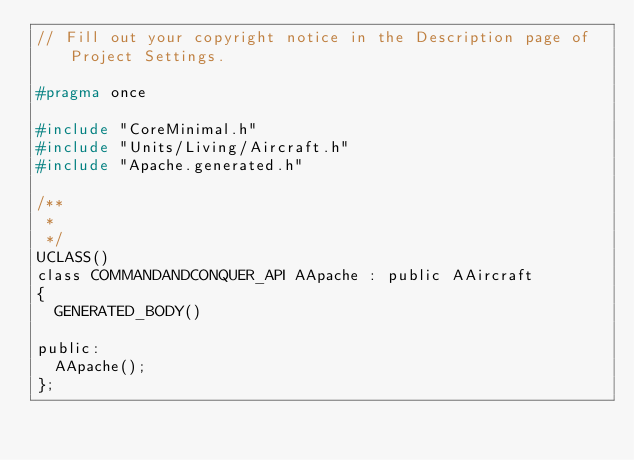Convert code to text. <code><loc_0><loc_0><loc_500><loc_500><_C_>// Fill out your copyright notice in the Description page of Project Settings.

#pragma once

#include "CoreMinimal.h"
#include "Units/Living/Aircraft.h"
#include "Apache.generated.h"

/**
 * 
 */
UCLASS()
class COMMANDANDCONQUER_API AApache : public AAircraft
{
	GENERATED_BODY()

public:
	AApache();	
};
</code> 